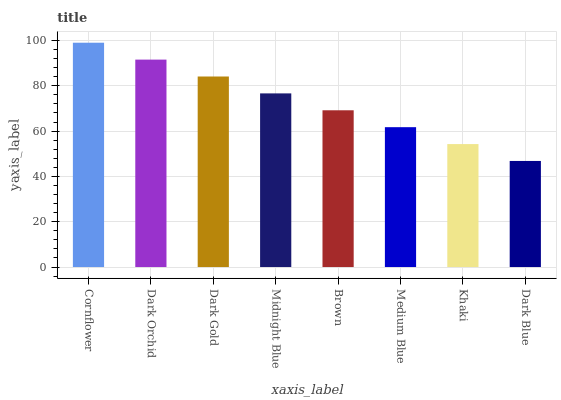Is Dark Orchid the minimum?
Answer yes or no. No. Is Dark Orchid the maximum?
Answer yes or no. No. Is Cornflower greater than Dark Orchid?
Answer yes or no. Yes. Is Dark Orchid less than Cornflower?
Answer yes or no. Yes. Is Dark Orchid greater than Cornflower?
Answer yes or no. No. Is Cornflower less than Dark Orchid?
Answer yes or no. No. Is Midnight Blue the high median?
Answer yes or no. Yes. Is Brown the low median?
Answer yes or no. Yes. Is Dark Orchid the high median?
Answer yes or no. No. Is Midnight Blue the low median?
Answer yes or no. No. 